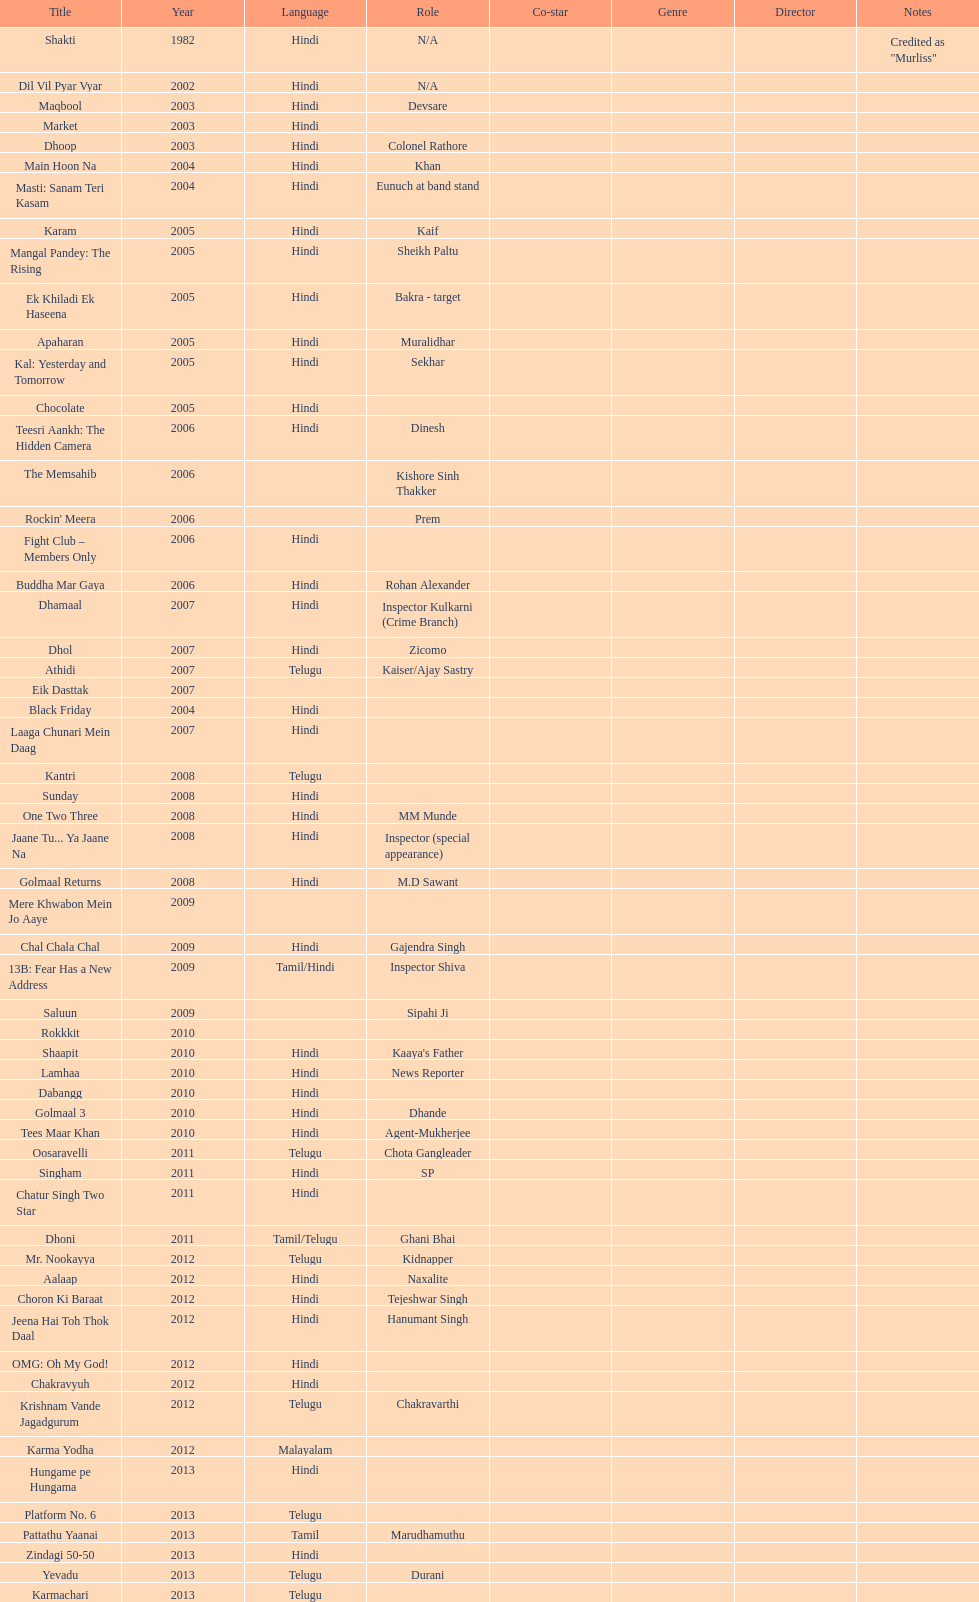What title is before dhol in 2007? Dhamaal. 